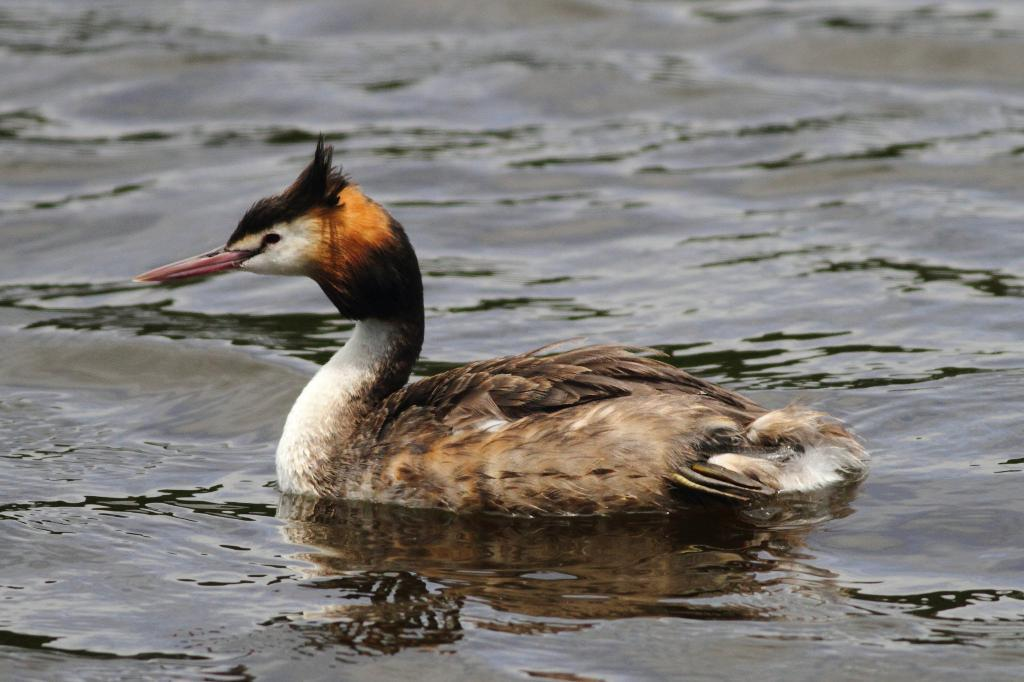What animal is present in the image? There is a duck in the image. Where is the duck located? The duck is in the water. Where is the faucet located in the image? There is no faucet present in the image. Is the duck in jail in the image? There is no jail present in the image, and the duck is not depicted as being confined or restricted. 